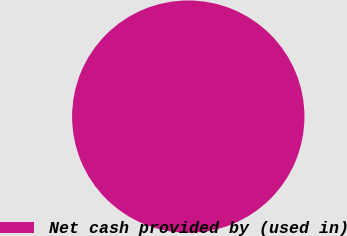Convert chart. <chart><loc_0><loc_0><loc_500><loc_500><pie_chart><fcel>Net cash provided by (used in)<nl><fcel>100.0%<nl></chart> 